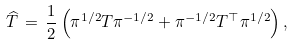Convert formula to latex. <formula><loc_0><loc_0><loc_500><loc_500>\widehat { T } \, = \, \frac { 1 } { 2 } \left ( \pi ^ { 1 / 2 } T \pi ^ { - 1 / 2 } + \pi ^ { - 1 / 2 } T ^ { \top } \pi ^ { 1 / 2 } \right ) ,</formula> 